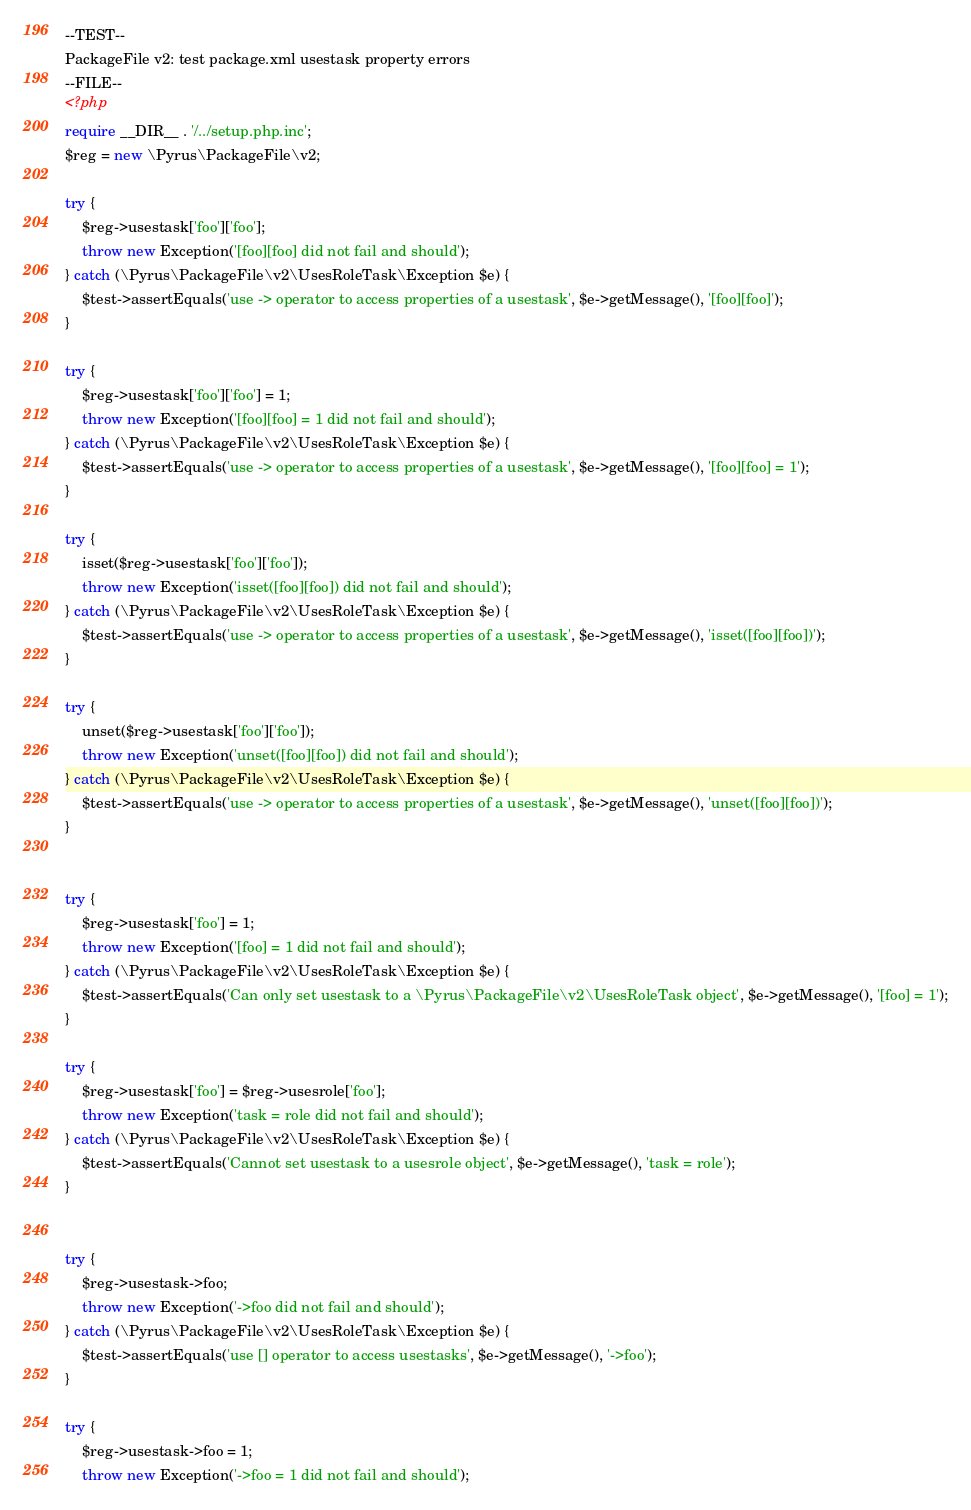<code> <loc_0><loc_0><loc_500><loc_500><_PHP_>--TEST--
PackageFile v2: test package.xml usestask property errors
--FILE--
<?php
require __DIR__ . '/../setup.php.inc';
$reg = new \Pyrus\PackageFile\v2;

try {
    $reg->usestask['foo']['foo'];
    throw new Exception('[foo][foo] did not fail and should');
} catch (\Pyrus\PackageFile\v2\UsesRoleTask\Exception $e) {
    $test->assertEquals('use -> operator to access properties of a usestask', $e->getMessage(), '[foo][foo]');
}

try {
    $reg->usestask['foo']['foo'] = 1;
    throw new Exception('[foo][foo] = 1 did not fail and should');
} catch (\Pyrus\PackageFile\v2\UsesRoleTask\Exception $e) {
    $test->assertEquals('use -> operator to access properties of a usestask', $e->getMessage(), '[foo][foo] = 1');
}

try {
    isset($reg->usestask['foo']['foo']);
    throw new Exception('isset([foo][foo]) did not fail and should');
} catch (\Pyrus\PackageFile\v2\UsesRoleTask\Exception $e) {
    $test->assertEquals('use -> operator to access properties of a usestask', $e->getMessage(), 'isset([foo][foo])');
}

try {
    unset($reg->usestask['foo']['foo']);
    throw new Exception('unset([foo][foo]) did not fail and should');
} catch (\Pyrus\PackageFile\v2\UsesRoleTask\Exception $e) {
    $test->assertEquals('use -> operator to access properties of a usestask', $e->getMessage(), 'unset([foo][foo])');
}


try {
    $reg->usestask['foo'] = 1;
    throw new Exception('[foo] = 1 did not fail and should');
} catch (\Pyrus\PackageFile\v2\UsesRoleTask\Exception $e) {
    $test->assertEquals('Can only set usestask to a \Pyrus\PackageFile\v2\UsesRoleTask object', $e->getMessage(), '[foo] = 1');
}

try {
    $reg->usestask['foo'] = $reg->usesrole['foo'];
    throw new Exception('task = role did not fail and should');
} catch (\Pyrus\PackageFile\v2\UsesRoleTask\Exception $e) {
    $test->assertEquals('Cannot set usestask to a usesrole object', $e->getMessage(), 'task = role');
}


try {
    $reg->usestask->foo;
    throw new Exception('->foo did not fail and should');
} catch (\Pyrus\PackageFile\v2\UsesRoleTask\Exception $e) {
    $test->assertEquals('use [] operator to access usestasks', $e->getMessage(), '->foo');
}

try {
    $reg->usestask->foo = 1;
    throw new Exception('->foo = 1 did not fail and should');</code> 